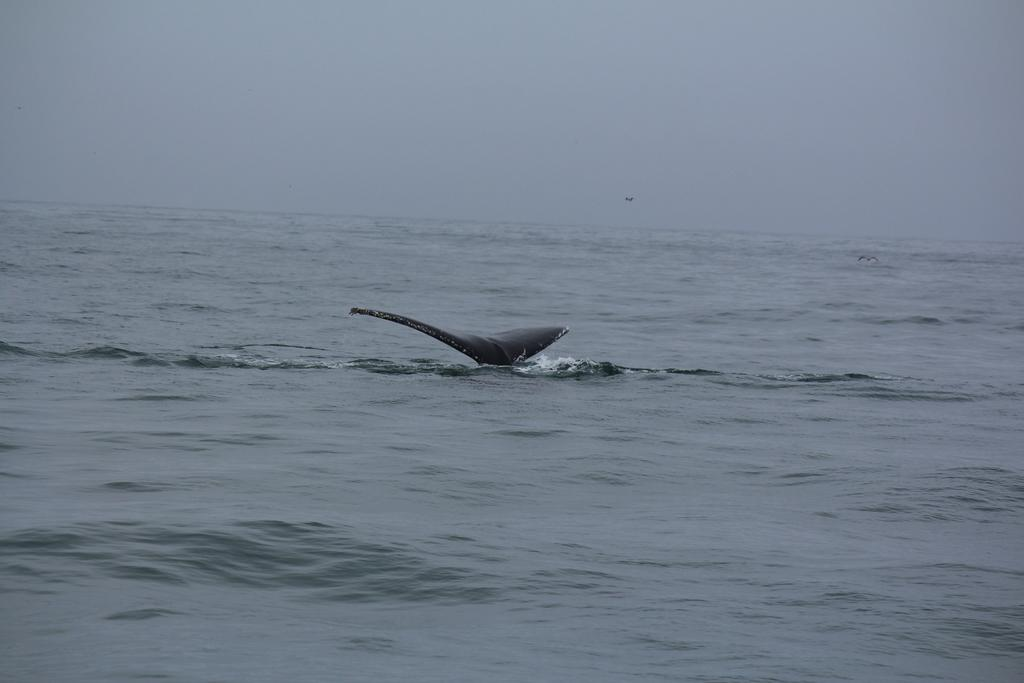What type of animal can be seen in the image? There is a water animal in the image. What is the water animal doing in the image? The water animal is swimming in the image. Where is the water animal located in the image? The water animal is in the ocean in the image. What color is the yak that is present in the image? There is no yak present in the image; it features a water animal in the ocean. 